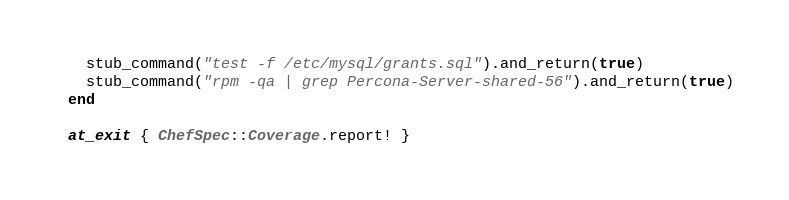<code> <loc_0><loc_0><loc_500><loc_500><_Ruby_>  stub_command("test -f /etc/mysql/grants.sql").and_return(true)
  stub_command("rpm -qa | grep Percona-Server-shared-56").and_return(true)
end

at_exit { ChefSpec::Coverage.report! }
</code> 